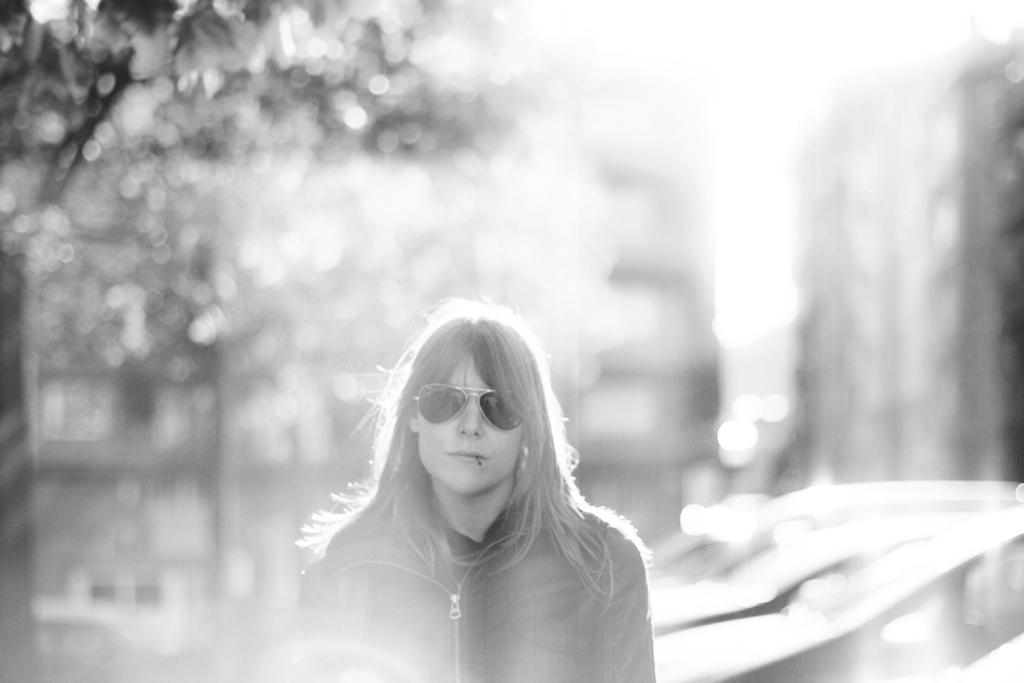Who is the main subject in the foreground of the image? There is a woman in the foreground of the image. What is the woman wearing on her face? The woman is wearing goggles. What can be seen in the background of the image? There are buildings, trees, and cars in the background of the image. What type of steel is being used to construct the buildings in the image? There is no information about the type of steel used in the construction of the buildings in the image. 